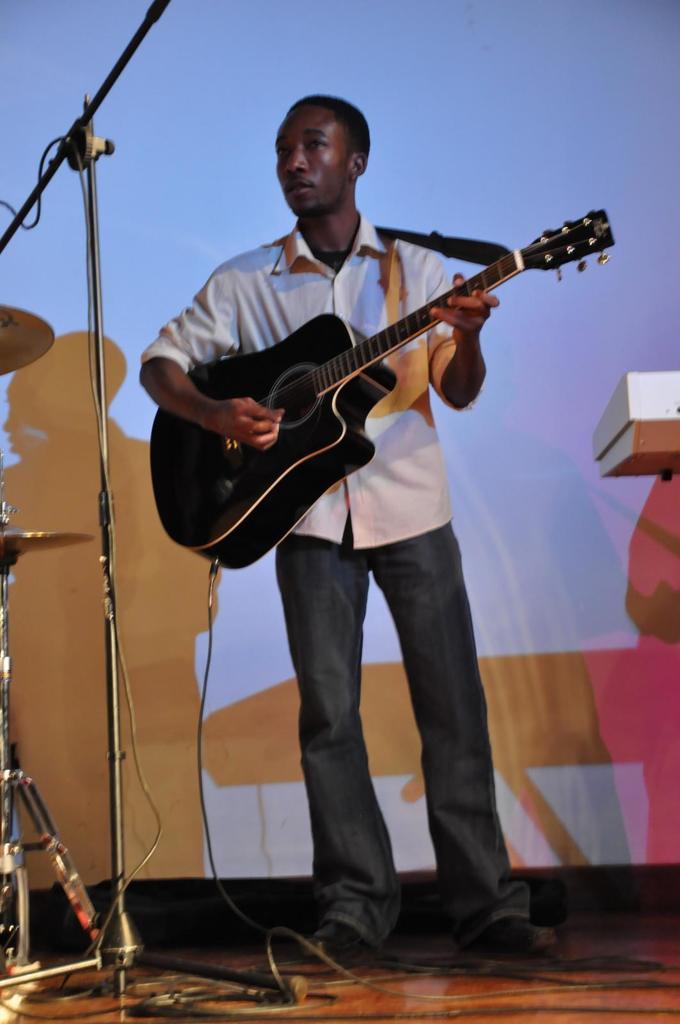Can you describe this image briefly? This image is clicked in a musical concert. There is a banner back side and there is a mic stand on the left. There is a person standing in the middle. he is holding guitar which is in black colour, he is wearing white colour shirt and black colour pant. On the right side there might be a keyboard. On the left side there are drums. In the bottom there are wires. 